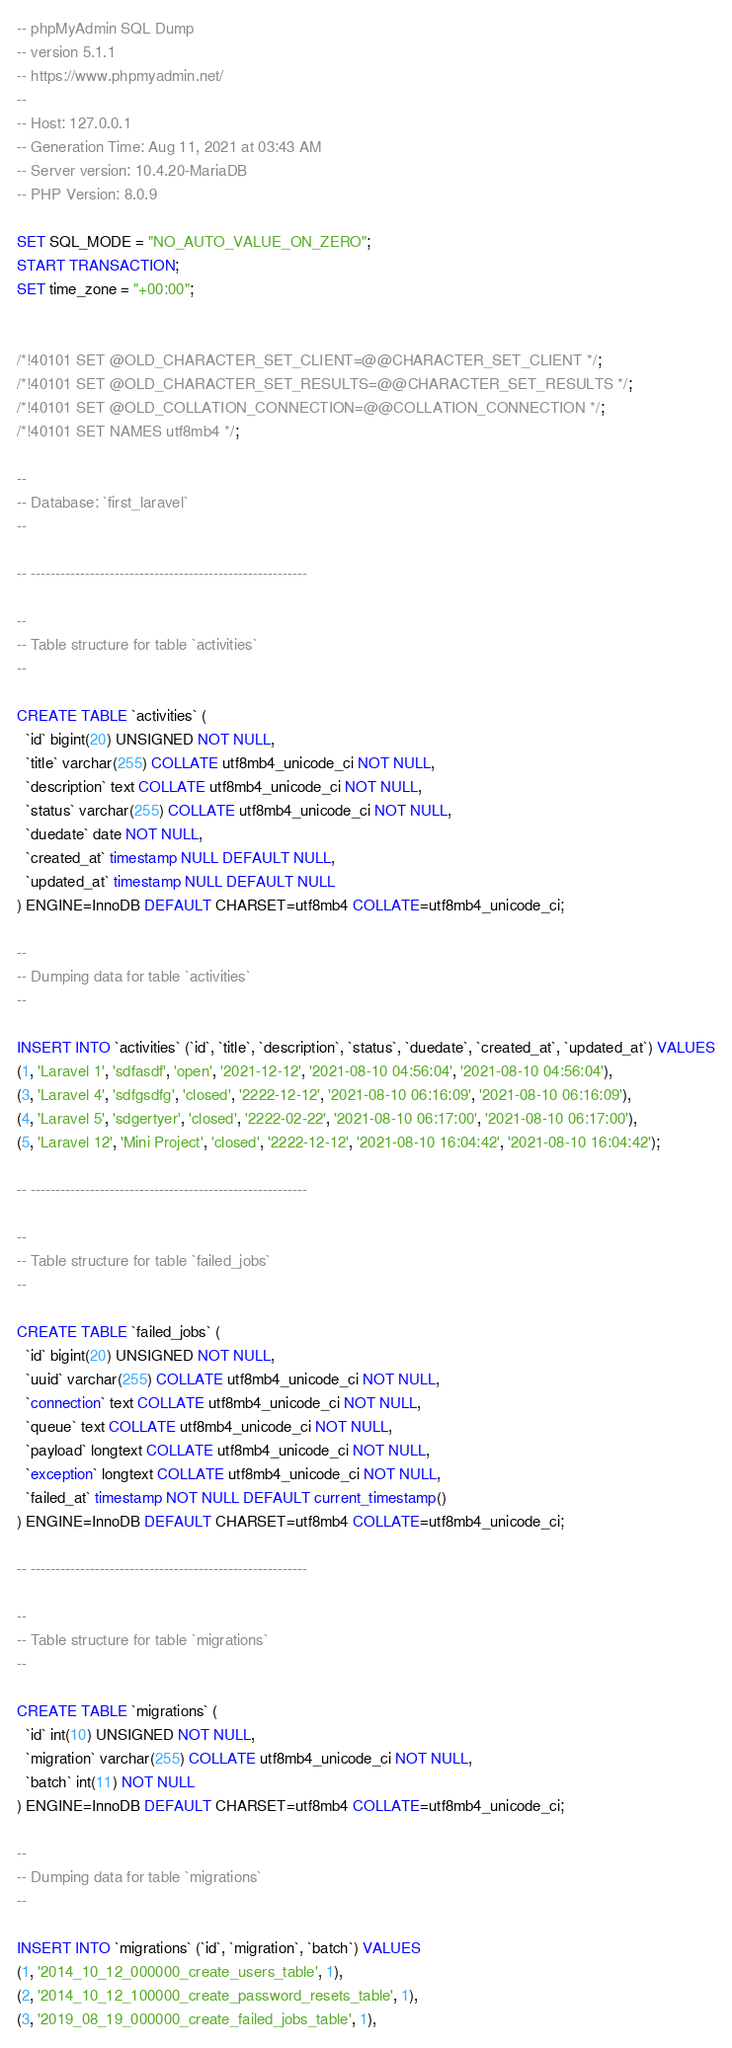<code> <loc_0><loc_0><loc_500><loc_500><_SQL_>-- phpMyAdmin SQL Dump
-- version 5.1.1
-- https://www.phpmyadmin.net/
--
-- Host: 127.0.0.1
-- Generation Time: Aug 11, 2021 at 03:43 AM
-- Server version: 10.4.20-MariaDB
-- PHP Version: 8.0.9

SET SQL_MODE = "NO_AUTO_VALUE_ON_ZERO";
START TRANSACTION;
SET time_zone = "+00:00";


/*!40101 SET @OLD_CHARACTER_SET_CLIENT=@@CHARACTER_SET_CLIENT */;
/*!40101 SET @OLD_CHARACTER_SET_RESULTS=@@CHARACTER_SET_RESULTS */;
/*!40101 SET @OLD_COLLATION_CONNECTION=@@COLLATION_CONNECTION */;
/*!40101 SET NAMES utf8mb4 */;

--
-- Database: `first_laravel`
--

-- --------------------------------------------------------

--
-- Table structure for table `activities`
--

CREATE TABLE `activities` (
  `id` bigint(20) UNSIGNED NOT NULL,
  `title` varchar(255) COLLATE utf8mb4_unicode_ci NOT NULL,
  `description` text COLLATE utf8mb4_unicode_ci NOT NULL,
  `status` varchar(255) COLLATE utf8mb4_unicode_ci NOT NULL,
  `duedate` date NOT NULL,
  `created_at` timestamp NULL DEFAULT NULL,
  `updated_at` timestamp NULL DEFAULT NULL
) ENGINE=InnoDB DEFAULT CHARSET=utf8mb4 COLLATE=utf8mb4_unicode_ci;

--
-- Dumping data for table `activities`
--

INSERT INTO `activities` (`id`, `title`, `description`, `status`, `duedate`, `created_at`, `updated_at`) VALUES
(1, 'Laravel 1', 'sdfasdf', 'open', '2021-12-12', '2021-08-10 04:56:04', '2021-08-10 04:56:04'),
(3, 'Laravel 4', 'sdfgsdfg', 'closed', '2222-12-12', '2021-08-10 06:16:09', '2021-08-10 06:16:09'),
(4, 'Laravel 5', 'sdgertyer', 'closed', '2222-02-22', '2021-08-10 06:17:00', '2021-08-10 06:17:00'),
(5, 'Laravel 12', 'Mini Project', 'closed', '2222-12-12', '2021-08-10 16:04:42', '2021-08-10 16:04:42');

-- --------------------------------------------------------

--
-- Table structure for table `failed_jobs`
--

CREATE TABLE `failed_jobs` (
  `id` bigint(20) UNSIGNED NOT NULL,
  `uuid` varchar(255) COLLATE utf8mb4_unicode_ci NOT NULL,
  `connection` text COLLATE utf8mb4_unicode_ci NOT NULL,
  `queue` text COLLATE utf8mb4_unicode_ci NOT NULL,
  `payload` longtext COLLATE utf8mb4_unicode_ci NOT NULL,
  `exception` longtext COLLATE utf8mb4_unicode_ci NOT NULL,
  `failed_at` timestamp NOT NULL DEFAULT current_timestamp()
) ENGINE=InnoDB DEFAULT CHARSET=utf8mb4 COLLATE=utf8mb4_unicode_ci;

-- --------------------------------------------------------

--
-- Table structure for table `migrations`
--

CREATE TABLE `migrations` (
  `id` int(10) UNSIGNED NOT NULL,
  `migration` varchar(255) COLLATE utf8mb4_unicode_ci NOT NULL,
  `batch` int(11) NOT NULL
) ENGINE=InnoDB DEFAULT CHARSET=utf8mb4 COLLATE=utf8mb4_unicode_ci;

--
-- Dumping data for table `migrations`
--

INSERT INTO `migrations` (`id`, `migration`, `batch`) VALUES
(1, '2014_10_12_000000_create_users_table', 1),
(2, '2014_10_12_100000_create_password_resets_table', 1),
(3, '2019_08_19_000000_create_failed_jobs_table', 1),</code> 